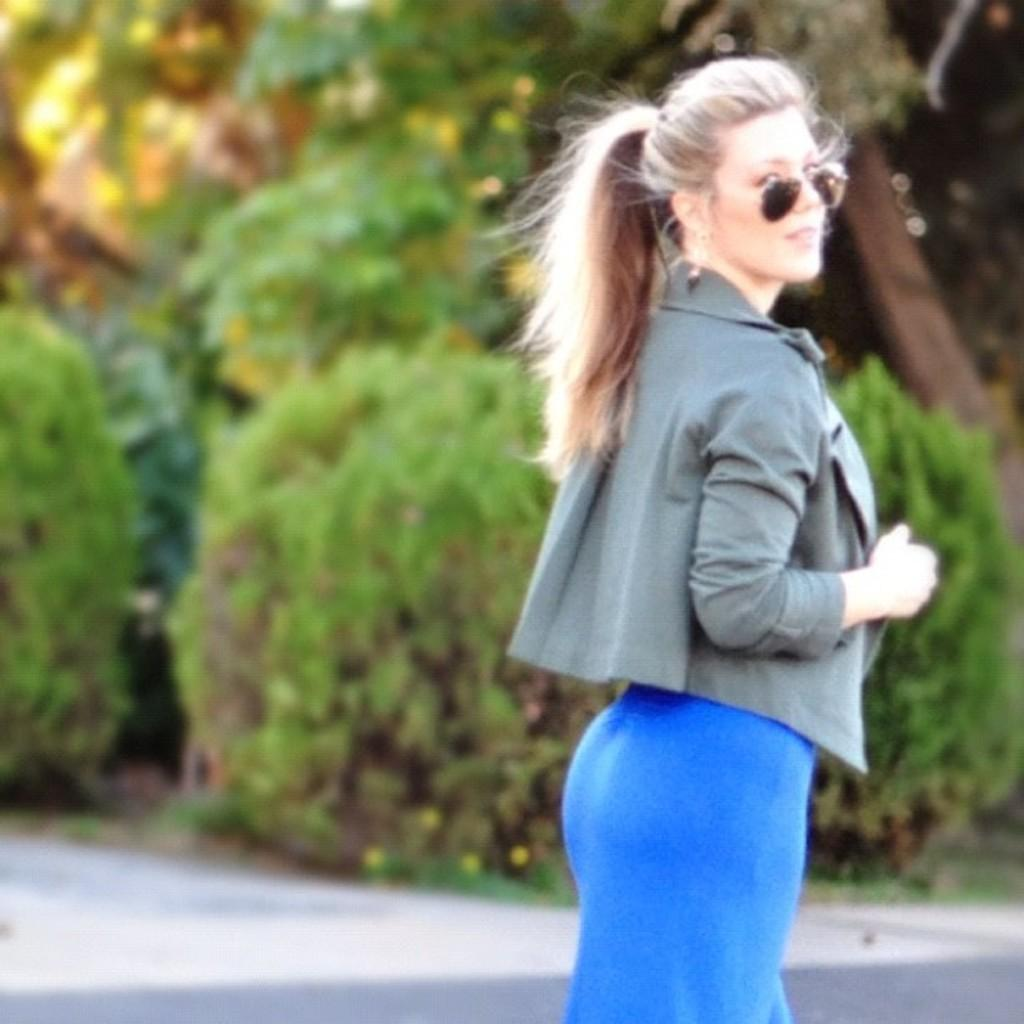Who is the main subject in the image? There is a woman in the picture. What is the woman doing in the image? The woman is standing on the road and posing for a photo. What is the woman wearing that is related to her activity? The woman is wearing goggles. What can be seen in the background of the image? There are many trees in the background of the image. Where is the desk located in the image? There is no desk present in the image. What type of quiver is the woman holding in the image? There is no quiver present in the image. 